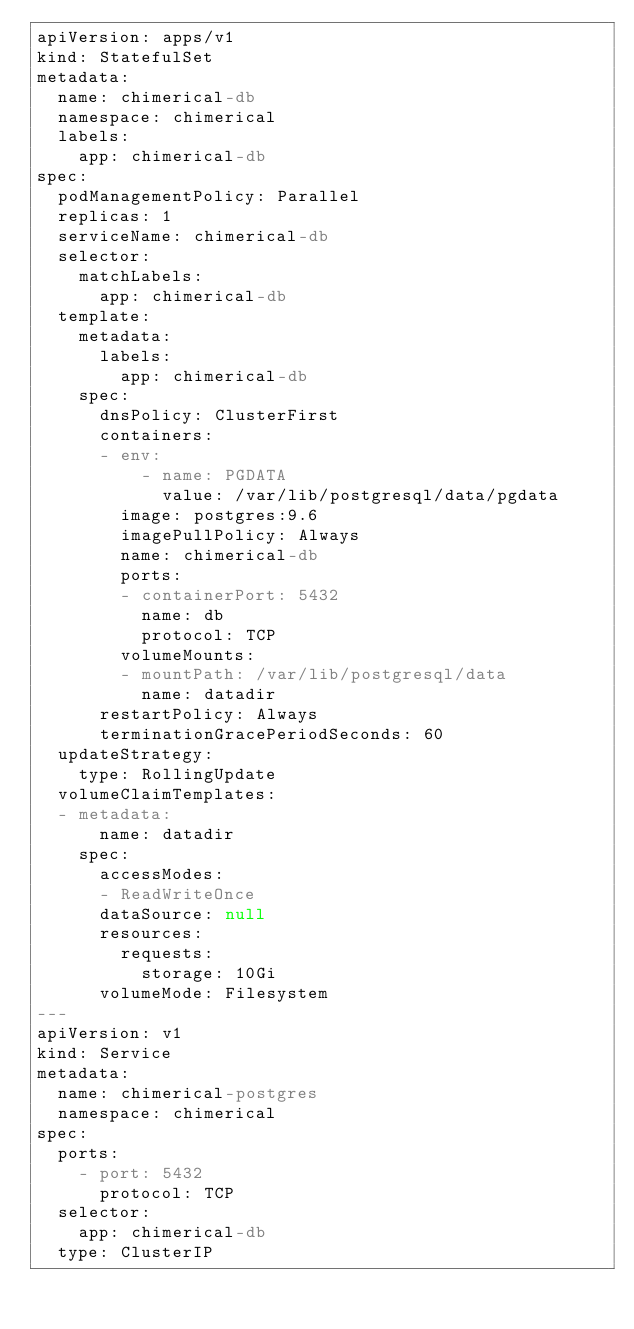Convert code to text. <code><loc_0><loc_0><loc_500><loc_500><_YAML_>apiVersion: apps/v1
kind: StatefulSet
metadata:
  name: chimerical-db
  namespace: chimerical
  labels:
    app: chimerical-db
spec:
  podManagementPolicy: Parallel
  replicas: 1
  serviceName: chimerical-db
  selector:
    matchLabels:
      app: chimerical-db
  template:
    metadata:
      labels:
        app: chimerical-db
    spec:
      dnsPolicy: ClusterFirst
      containers:
      - env:
          - name: PGDATA
            value: /var/lib/postgresql/data/pgdata
        image: postgres:9.6
        imagePullPolicy: Always
        name: chimerical-db
        ports:
        - containerPort: 5432
          name: db
          protocol: TCP
        volumeMounts:
        - mountPath: /var/lib/postgresql/data
          name: datadir
      restartPolicy: Always
      terminationGracePeriodSeconds: 60
  updateStrategy:
    type: RollingUpdate
  volumeClaimTemplates:
  - metadata:
      name: datadir
    spec:
      accessModes:
      - ReadWriteOnce
      dataSource: null
      resources:
        requests:
          storage: 10Gi
      volumeMode: Filesystem
---
apiVersion: v1
kind: Service
metadata:
  name: chimerical-postgres
  namespace: chimerical
spec:
  ports:
    - port: 5432
      protocol: TCP
  selector:
    app: chimerical-db
  type: ClusterIP
</code> 